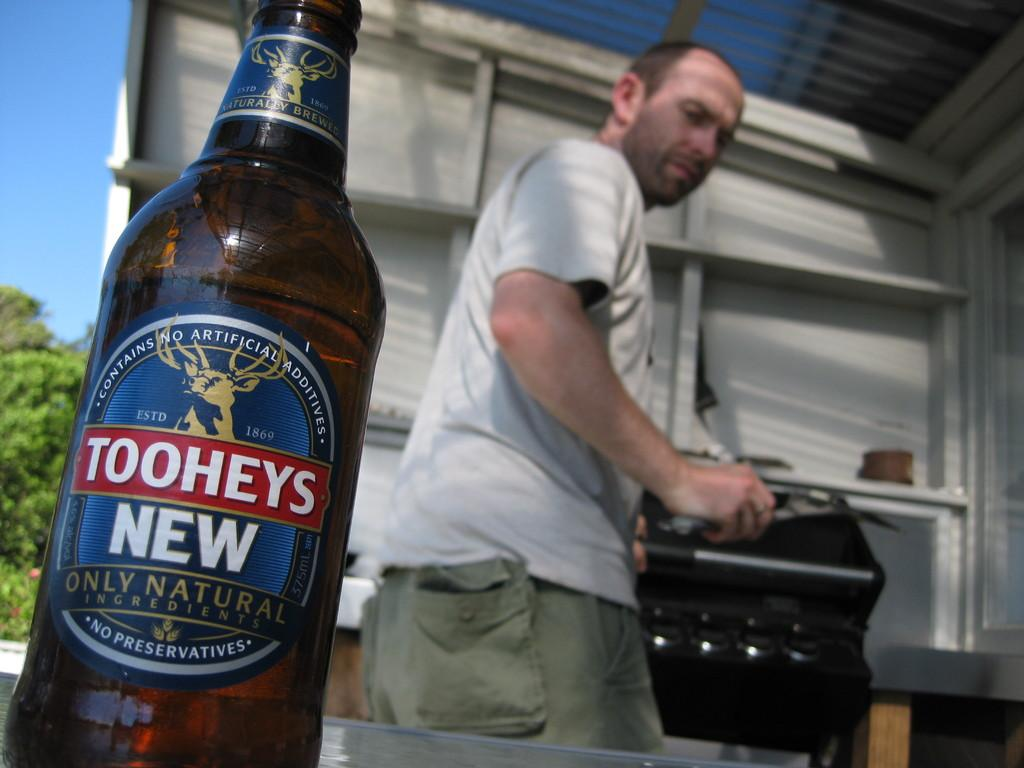<image>
Create a compact narrative representing the image presented. Man cooking behind a Toohey's only natural beer bottle. 